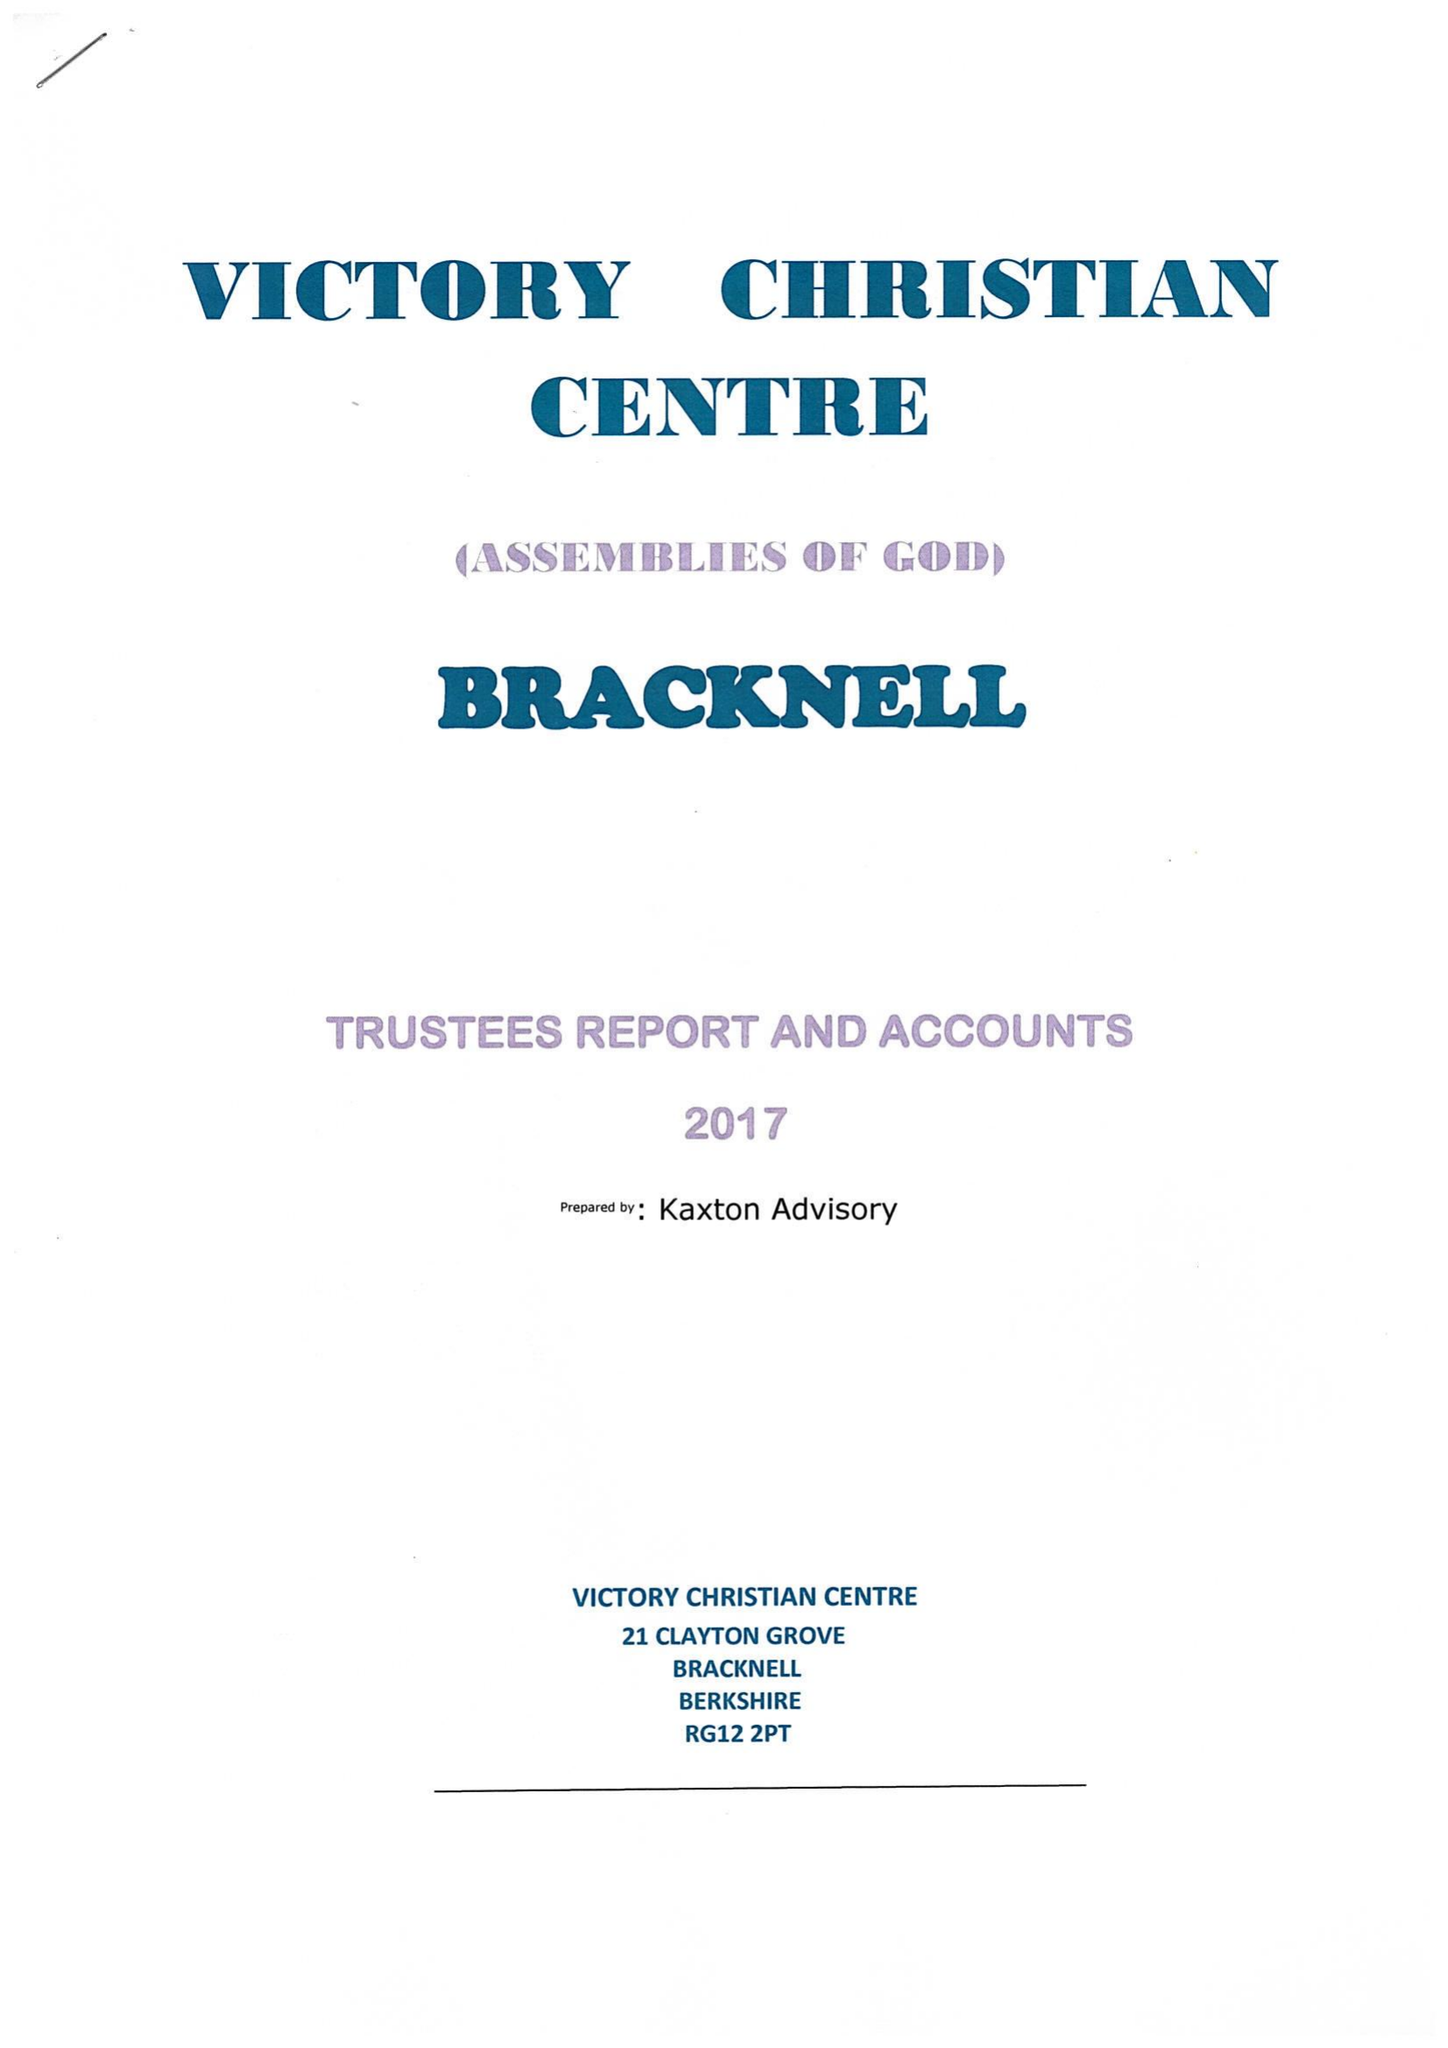What is the value for the charity_name?
Answer the question using a single word or phrase. Victory Christian Centre Assemblies Of God - Bracknell 